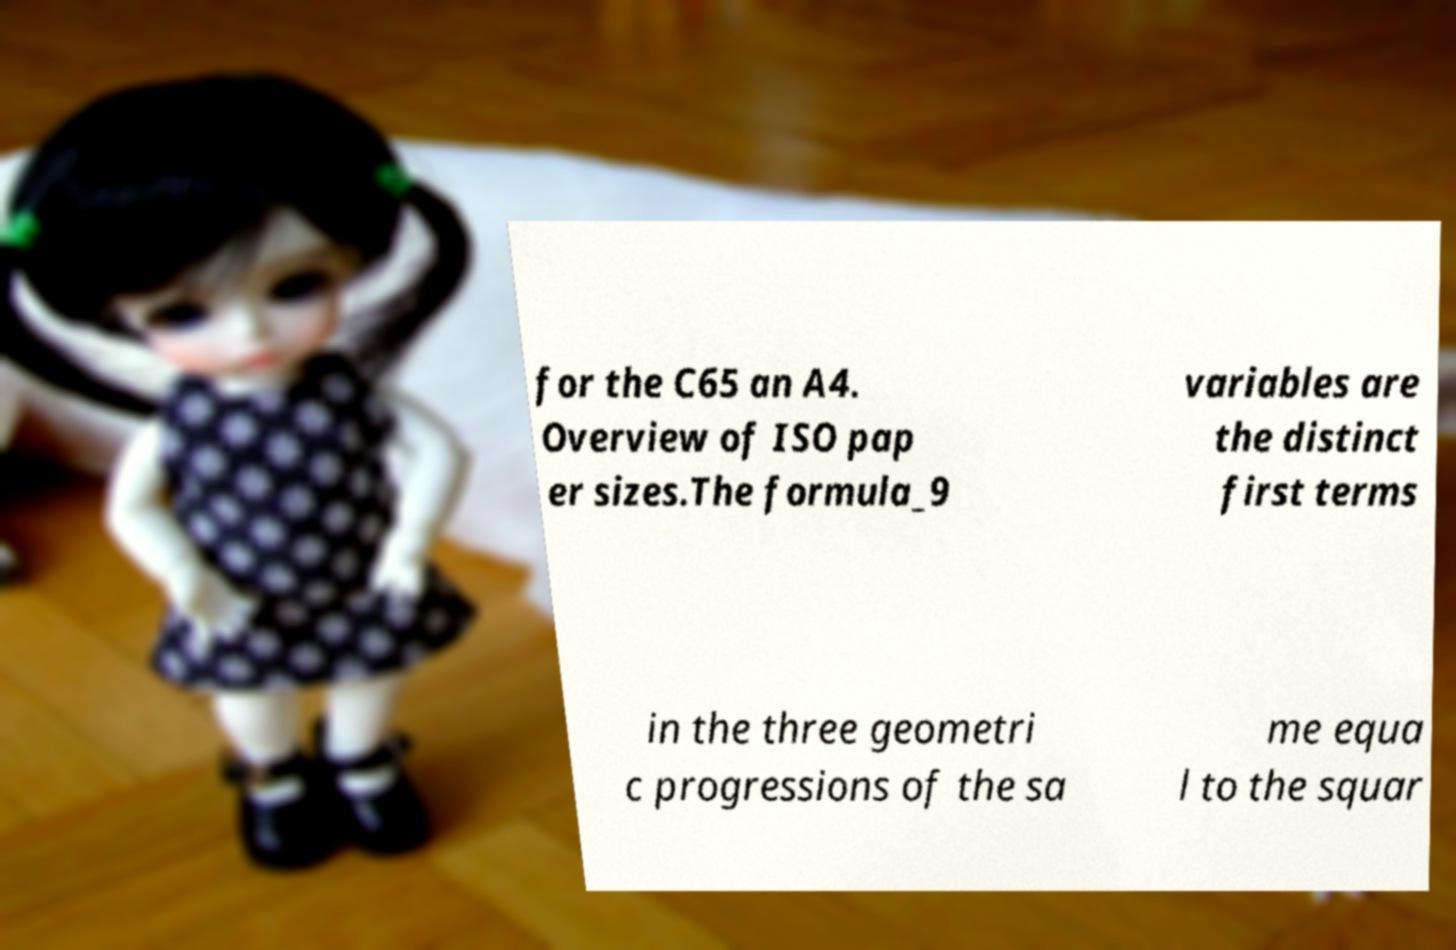What messages or text are displayed in this image? I need them in a readable, typed format. for the C65 an A4. Overview of ISO pap er sizes.The formula_9 variables are the distinct first terms in the three geometri c progressions of the sa me equa l to the squar 